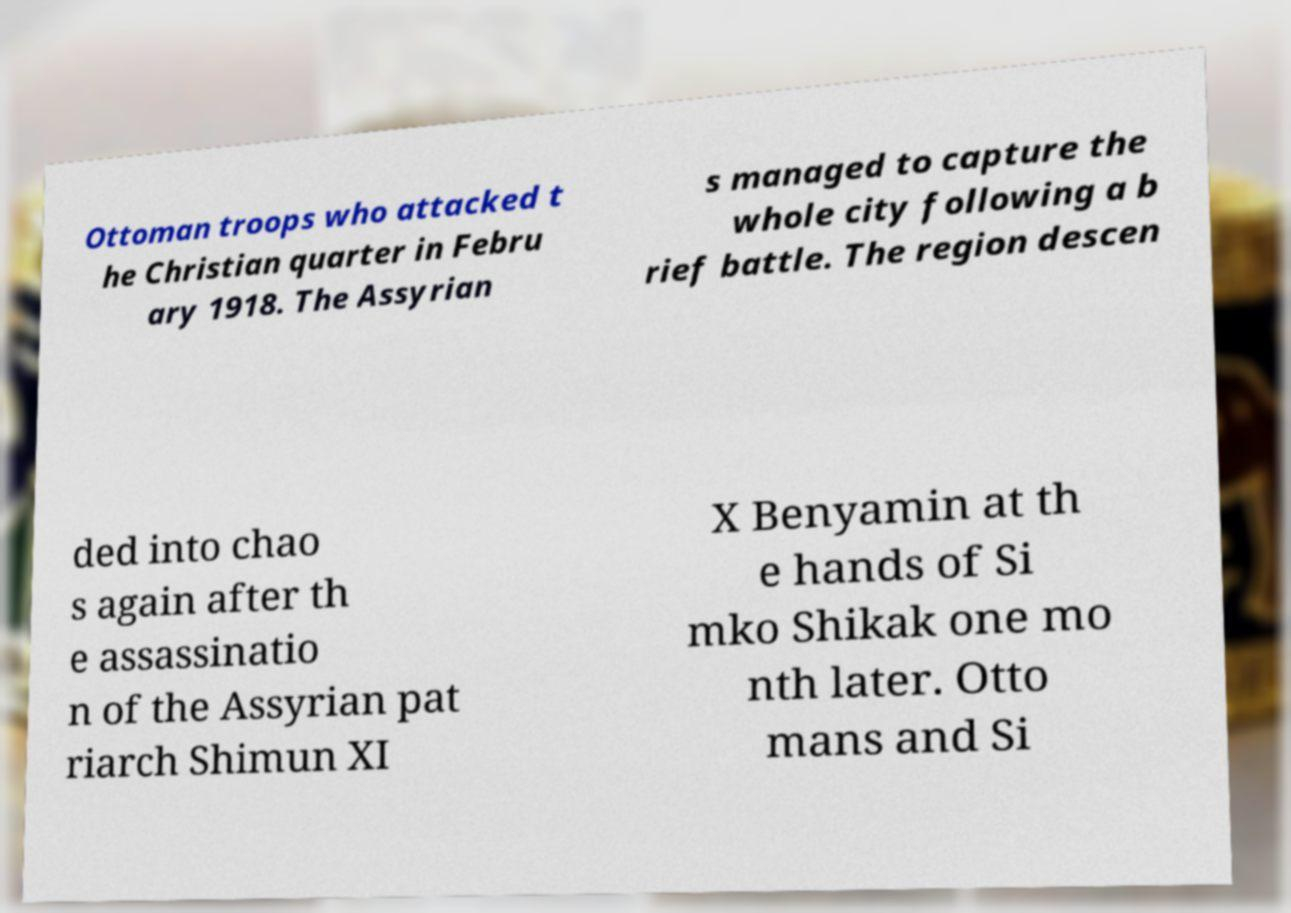Please identify and transcribe the text found in this image. Ottoman troops who attacked t he Christian quarter in Febru ary 1918. The Assyrian s managed to capture the whole city following a b rief battle. The region descen ded into chao s again after th e assassinatio n of the Assyrian pat riarch Shimun XI X Benyamin at th e hands of Si mko Shikak one mo nth later. Otto mans and Si 